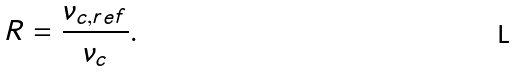Convert formula to latex. <formula><loc_0><loc_0><loc_500><loc_500>R = \frac { \nu _ { c , r e f } } { \nu _ { c } } .</formula> 